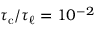<formula> <loc_0><loc_0><loc_500><loc_500>{ \tau _ { c } } / { \tau _ { \ell } } = 1 0 ^ { - 2 }</formula> 